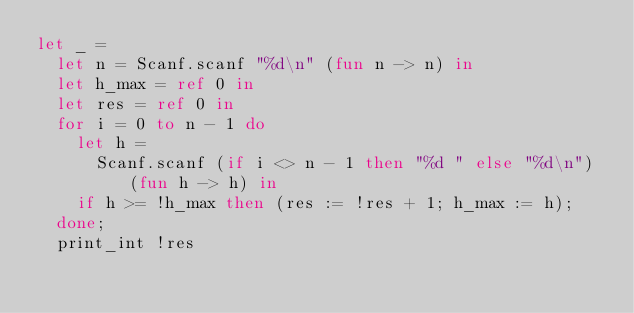<code> <loc_0><loc_0><loc_500><loc_500><_OCaml_>let _ =
  let n = Scanf.scanf "%d\n" (fun n -> n) in
  let h_max = ref 0 in
  let res = ref 0 in
  for i = 0 to n - 1 do
    let h = 
      Scanf.scanf (if i <> n - 1 then "%d " else "%d\n") (fun h -> h) in
    if h >= !h_max then (res := !res + 1; h_max := h);
  done;
  print_int !res
</code> 